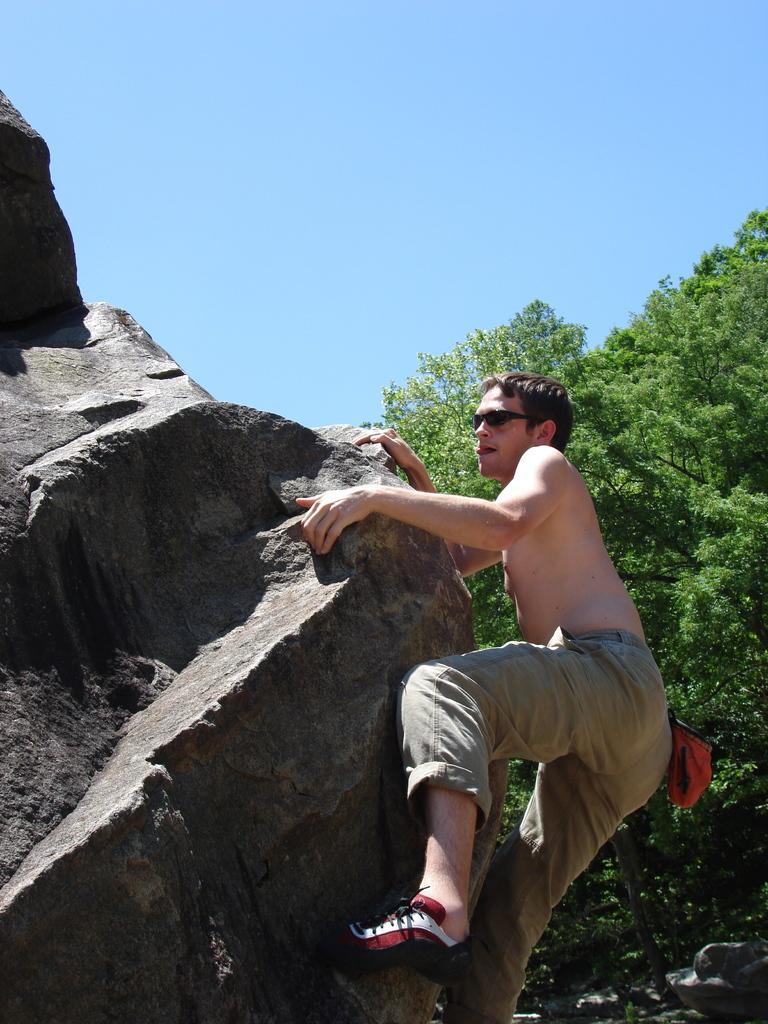Can you describe this image briefly? In this picture we can see man wore goggle, cap at his back trying to climb the rock and in background we can see trees, sky. 